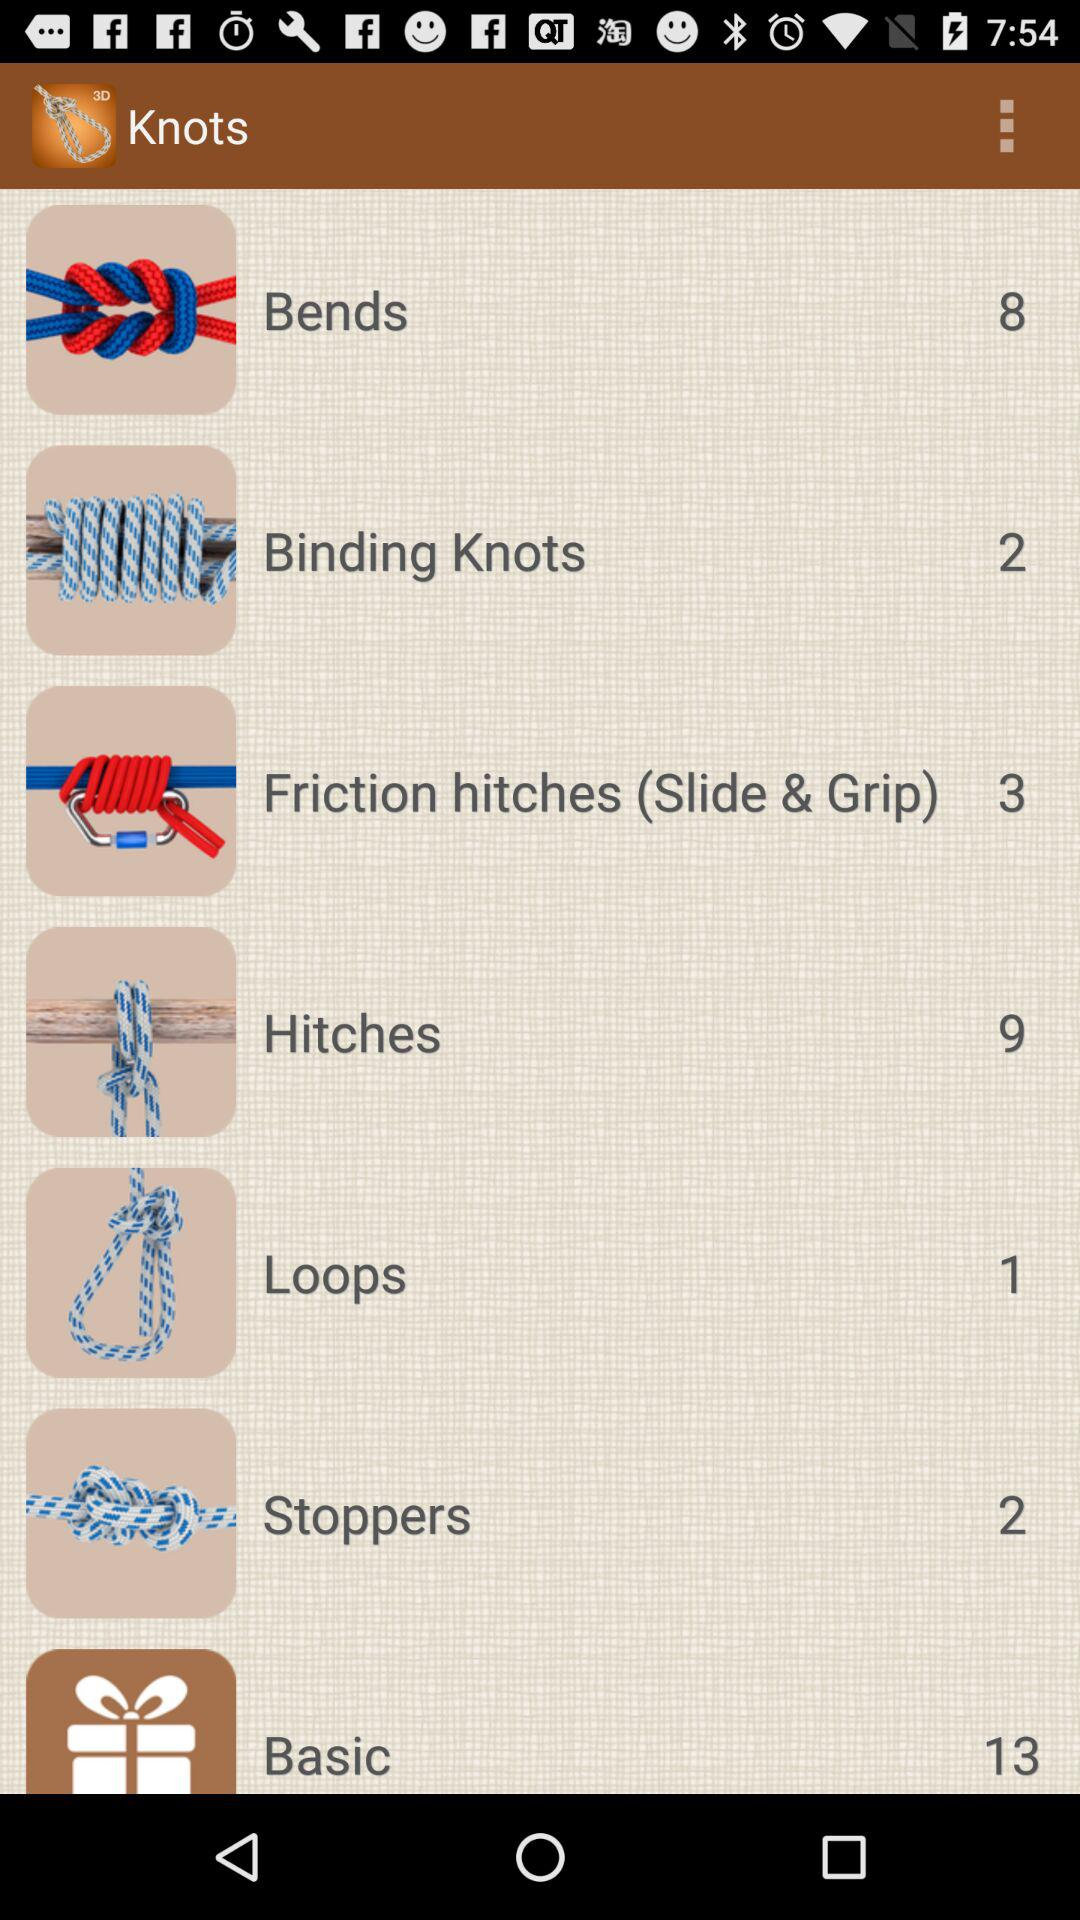How many knots are there in the "Bends"? There are 8 knots. 